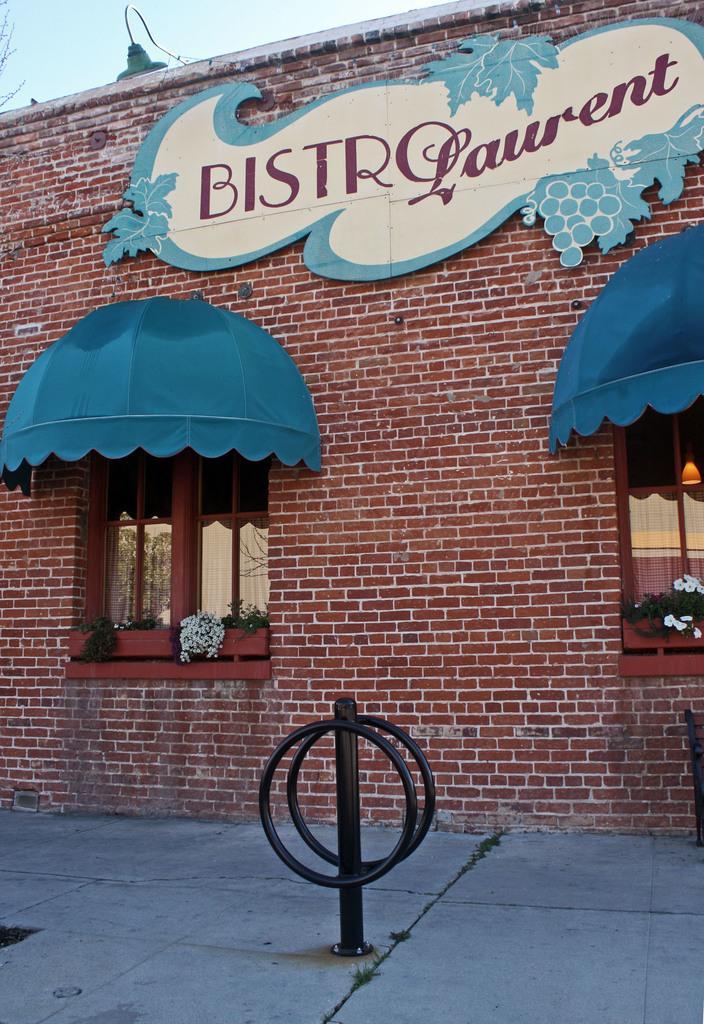How would you summarize this image in a sentence or two? In this image we can see a building, plants in the window and sky. 